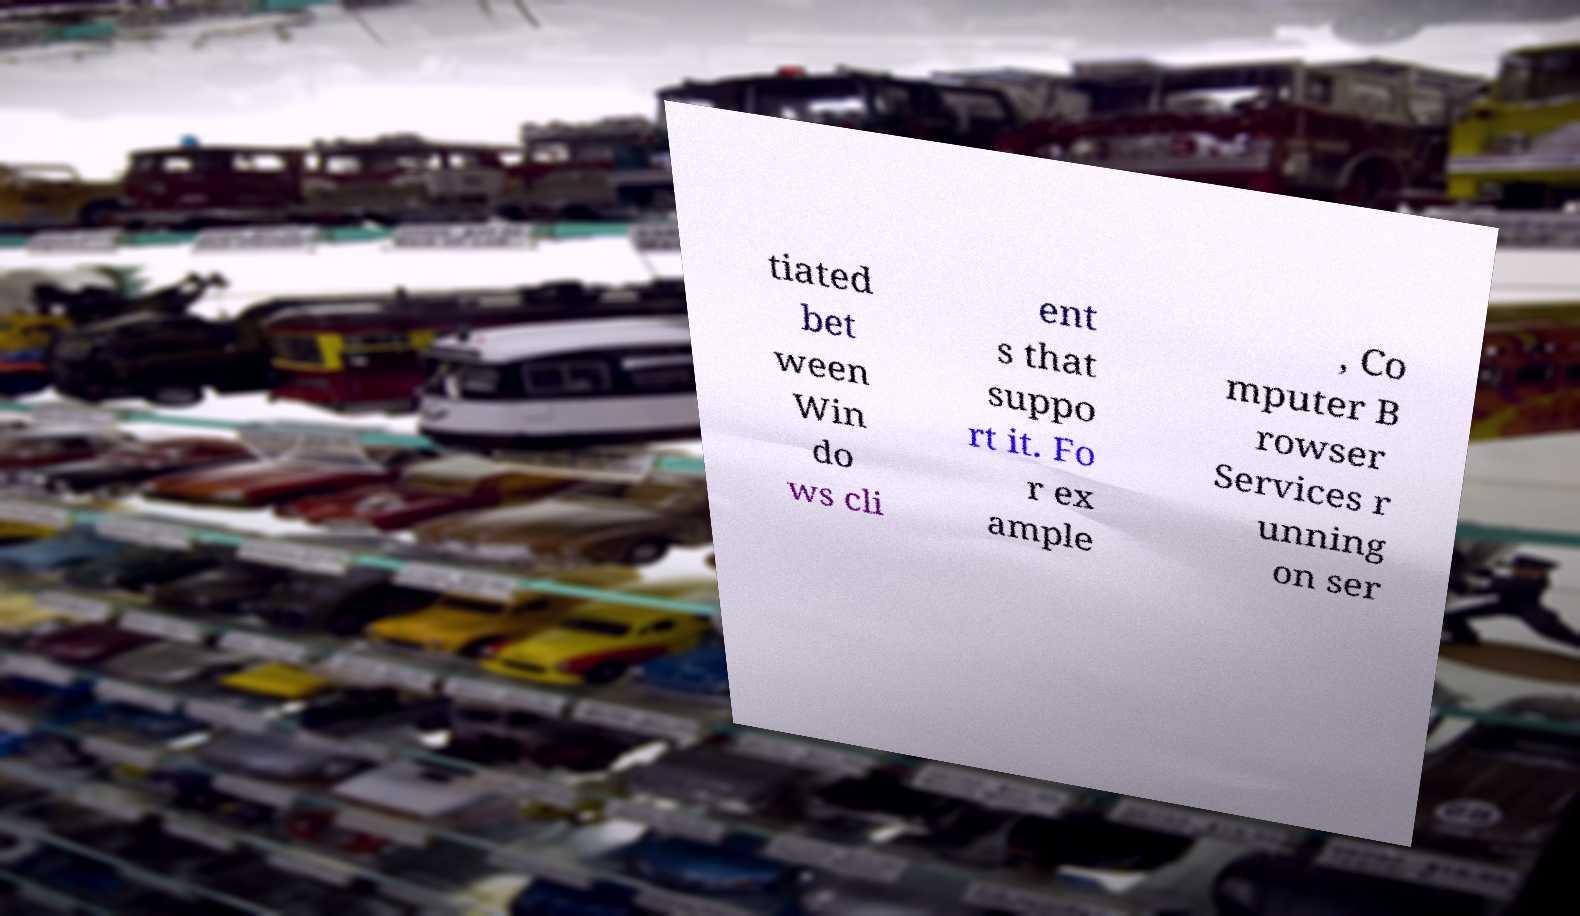Please identify and transcribe the text found in this image. tiated bet ween Win do ws cli ent s that suppo rt it. Fo r ex ample , Co mputer B rowser Services r unning on ser 